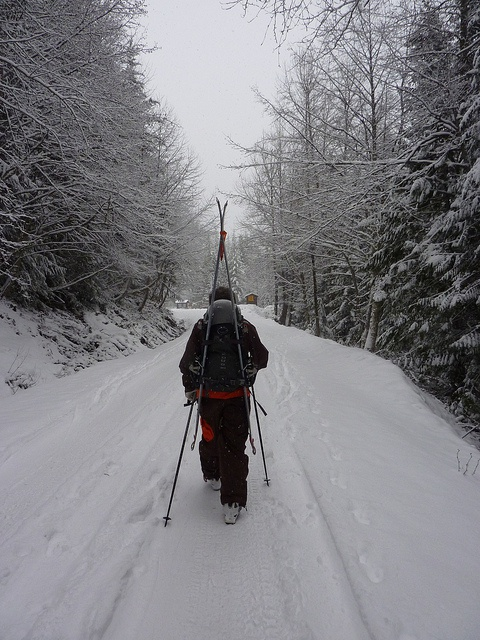Describe the objects in this image and their specific colors. I can see people in gray, black, maroon, and darkgray tones, skis in gray, black, darkgray, and lightgray tones, and backpack in gray and black tones in this image. 